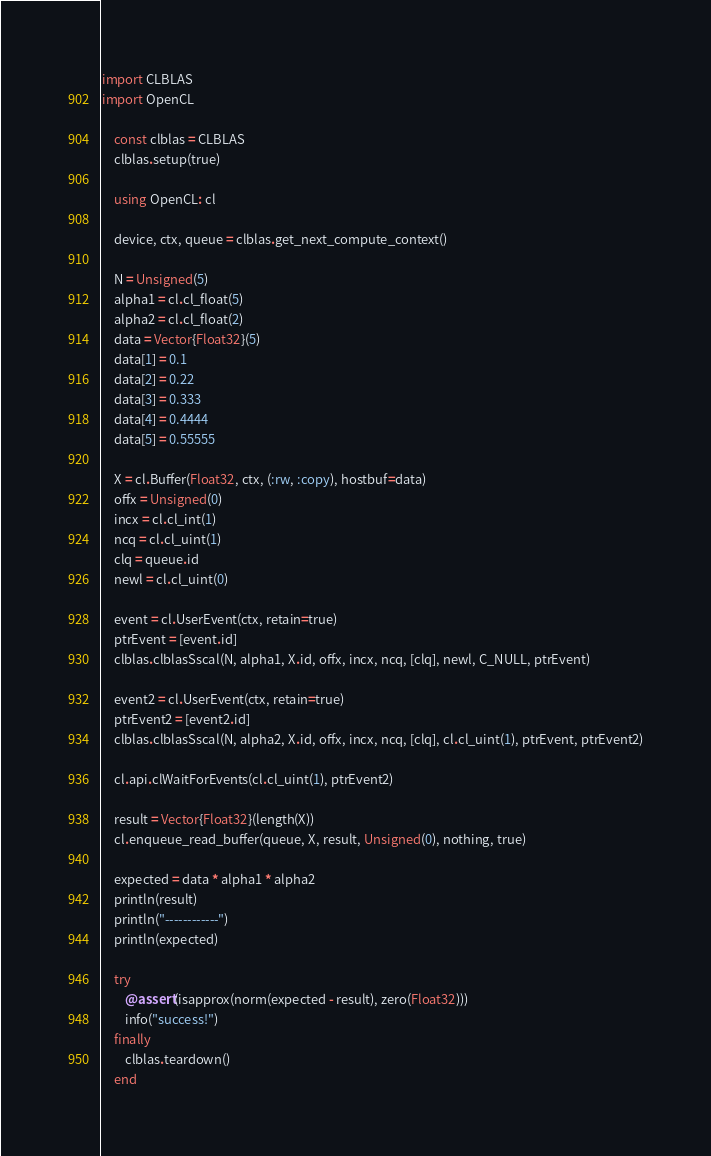Convert code to text. <code><loc_0><loc_0><loc_500><loc_500><_Julia_>import CLBLAS
import OpenCL

    const clblas = CLBLAS
    clblas.setup(true)
    
    using OpenCL: cl

    device, ctx, queue = clblas.get_next_compute_context()

    N = Unsigned(5)
    alpha1 = cl.cl_float(5)
    alpha2 = cl.cl_float(2)
    data = Vector{Float32}(5)
    data[1] = 0.1
    data[2] = 0.22
    data[3] = 0.333
    data[4] = 0.4444
    data[5] = 0.55555

    X = cl.Buffer(Float32, ctx, (:rw, :copy), hostbuf=data)
    offx = Unsigned(0)
    incx = cl.cl_int(1)
    ncq = cl.cl_uint(1)
    clq = queue.id
    newl = cl.cl_uint(0)

    event = cl.UserEvent(ctx, retain=true)
    ptrEvent = [event.id]
    clblas.clblasSscal(N, alpha1, X.id, offx, incx, ncq, [clq], newl, C_NULL, ptrEvent)

    event2 = cl.UserEvent(ctx, retain=true)
    ptrEvent2 = [event2.id]
    clblas.clblasSscal(N, alpha2, X.id, offx, incx, ncq, [clq], cl.cl_uint(1), ptrEvent, ptrEvent2)

    cl.api.clWaitForEvents(cl.cl_uint(1), ptrEvent2)

    result = Vector{Float32}(length(X))
    cl.enqueue_read_buffer(queue, X, result, Unsigned(0), nothing, true)
    
    expected = data * alpha1 * alpha2
    println(result)
    println("------------")
    println(expected)

    try
        @assert(isapprox(norm(expected - result), zero(Float32)))
        info("success!")
    finally
        clblas.teardown()
    end
</code> 